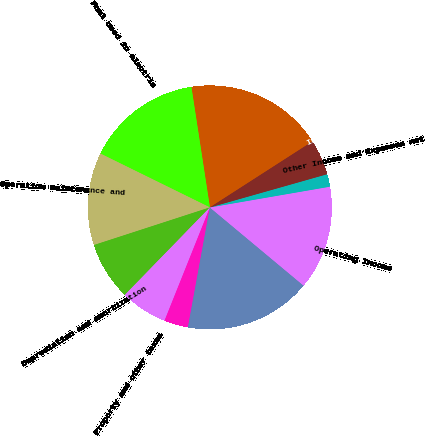<chart> <loc_0><loc_0><loc_500><loc_500><pie_chart><fcel>Operating Revenues<fcel>Fuel used in electric<fcel>Operation maintenance and<fcel>Depreciation and amortization<fcel>Property and other taxes<fcel>Impairment charges<fcel>Total operating expenses<fcel>Operating Income<fcel>Other Income and Expenses net<fcel>Interest Expense<nl><fcel>18.33%<fcel>15.3%<fcel>12.27%<fcel>7.73%<fcel>6.21%<fcel>3.18%<fcel>16.82%<fcel>13.79%<fcel>1.67%<fcel>4.7%<nl></chart> 